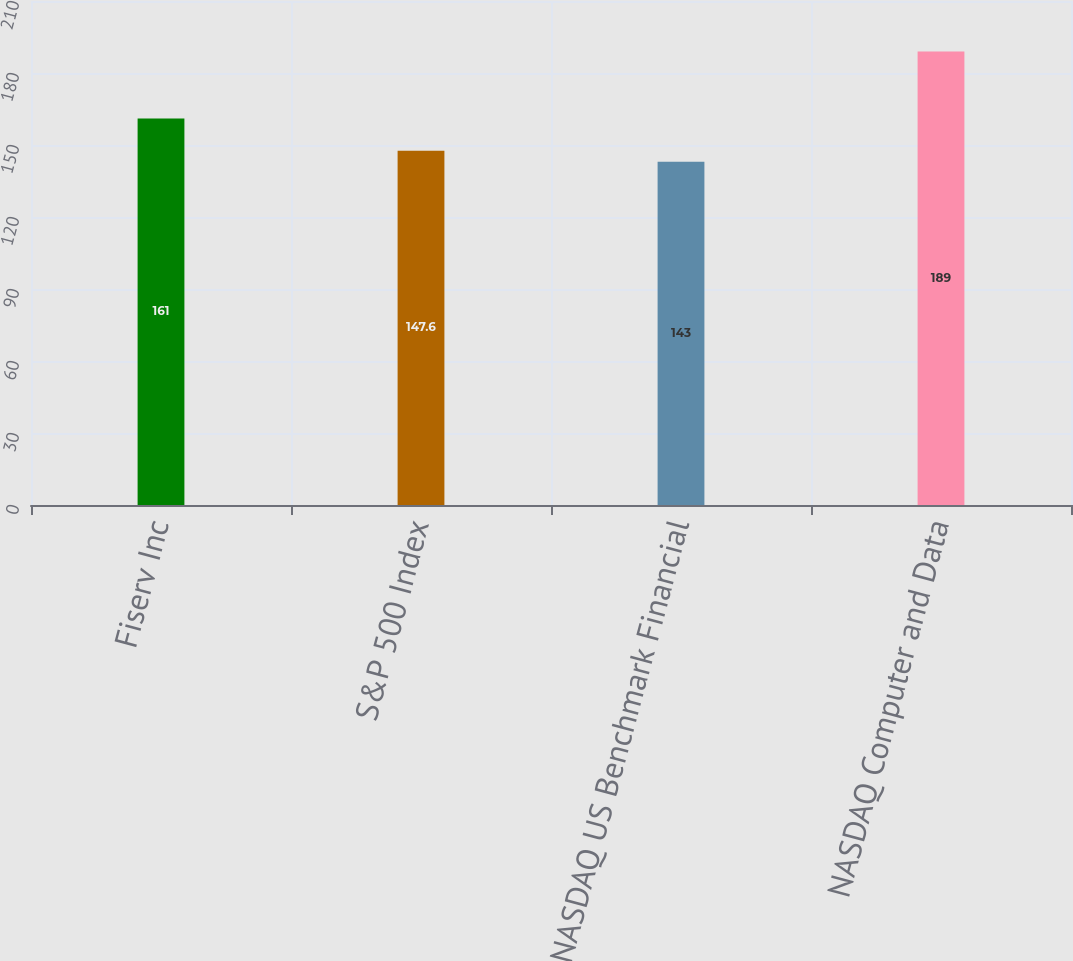<chart> <loc_0><loc_0><loc_500><loc_500><bar_chart><fcel>Fiserv Inc<fcel>S&P 500 Index<fcel>NASDAQ US Benchmark Financial<fcel>NASDAQ Computer and Data<nl><fcel>161<fcel>147.6<fcel>143<fcel>189<nl></chart> 